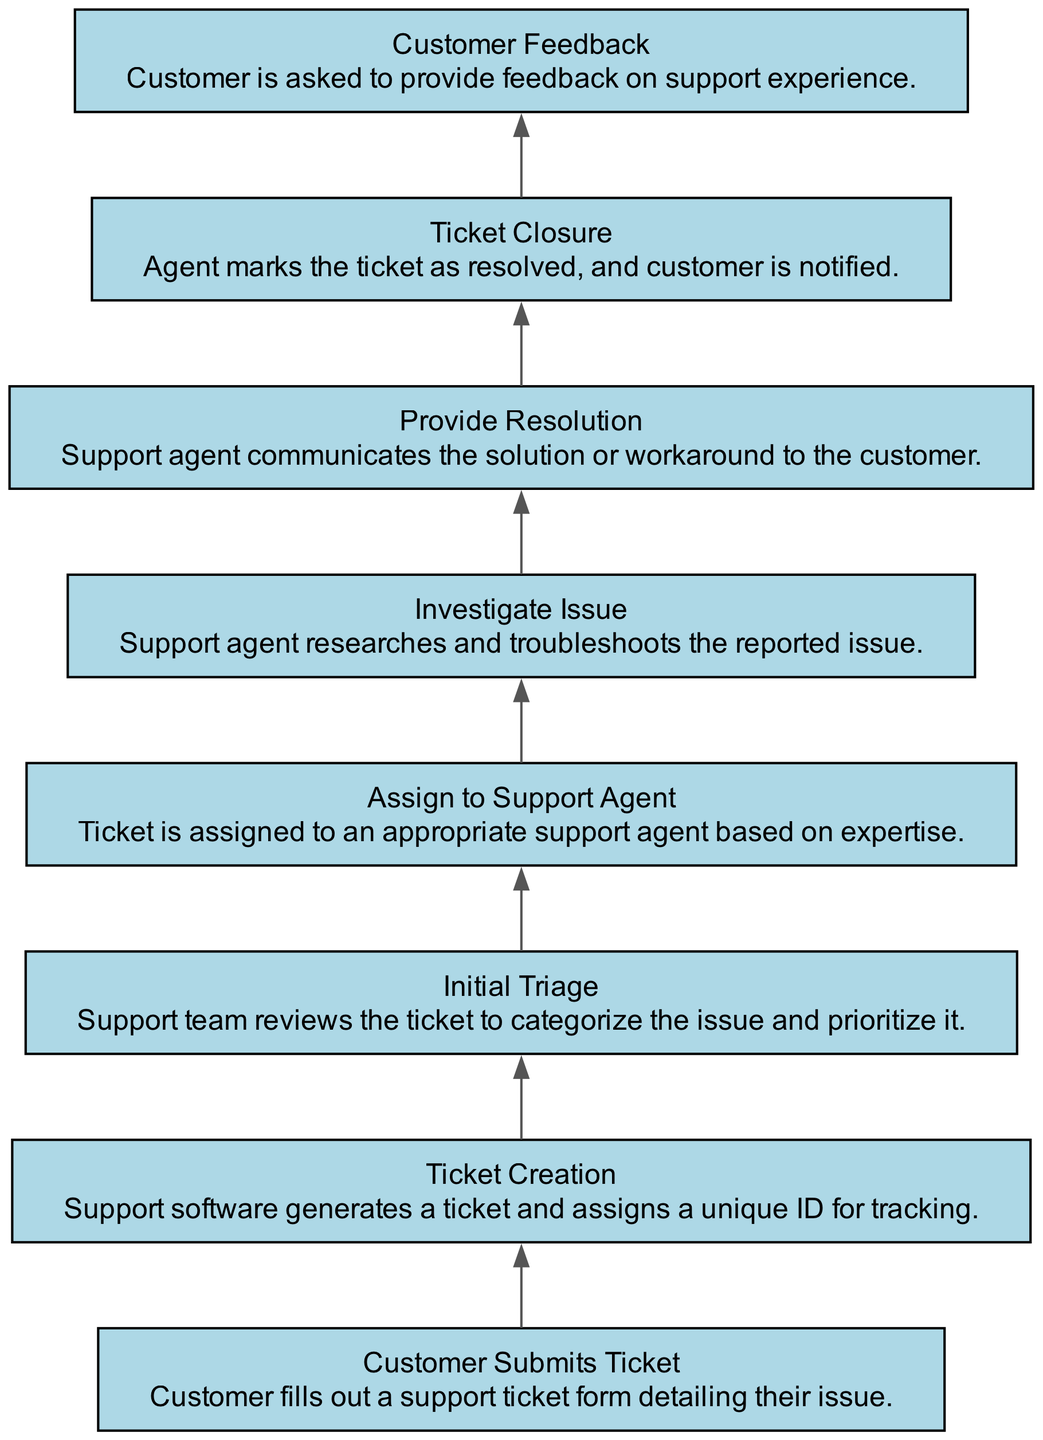What is the first step in the customer support ticket process? The first step listed in the diagram is "Customer Submits Ticket," which indicates that the process begins with the customer filling out a support ticket form.
Answer: Customer Submits Ticket How many total steps are in the flowchart? The flowchart includes a total of eight distinct steps that guide the process from ticket submission to final feedback.
Answer: 8 What comes after the "Initial Triage" step? The diagram shows that after the "Initial Triage," the next step is "Assign to Support Agent," indicating the flow of the ticketing process.
Answer: Assign to Support Agent What is the last action taken in the ticket handling steps? The final action in the flowchart is "Customer Feedback," which signifies that after a ticket is closed, customers are asked for their input on the support experience.
Answer: Customer Feedback Can you name the step where a ticket is assigned to a specific agent? The step where a ticket is assigned to a specific agent is labeled "Assign to Support Agent," which directly addresses the allocation of tasks based on expertise.
Answer: Assign to Support Agent Which two steps are directly connected before the "Provide Resolution"? Before "Provide Resolution," the steps that are directly connected are "Investigate Issue" and "Assign to Support Agent," indicating the sequence of actions leading to providing a solution.
Answer: Investigate Issue, Assign to Support Agent What type of graph is represented in this diagram? The diagram is a "Bottom Up Flow Chart," which illustrates the sequential steps in handling customer support tickets from the bottom to the top direction.
Answer: Bottom Up Flow Chart How many customer interaction points are there in the process? The diagram illustrates customer interaction at two points: during "Customer Submits Ticket" and "Customer Feedback," highlighting moments where customer input is solicited.
Answer: 2 What step indicates a ticket is reviewed by the support team? The step labeled "Initial Triage" specifically denotes that the support team reviews the tickets to categorize and prioritize issues.
Answer: Initial Triage 